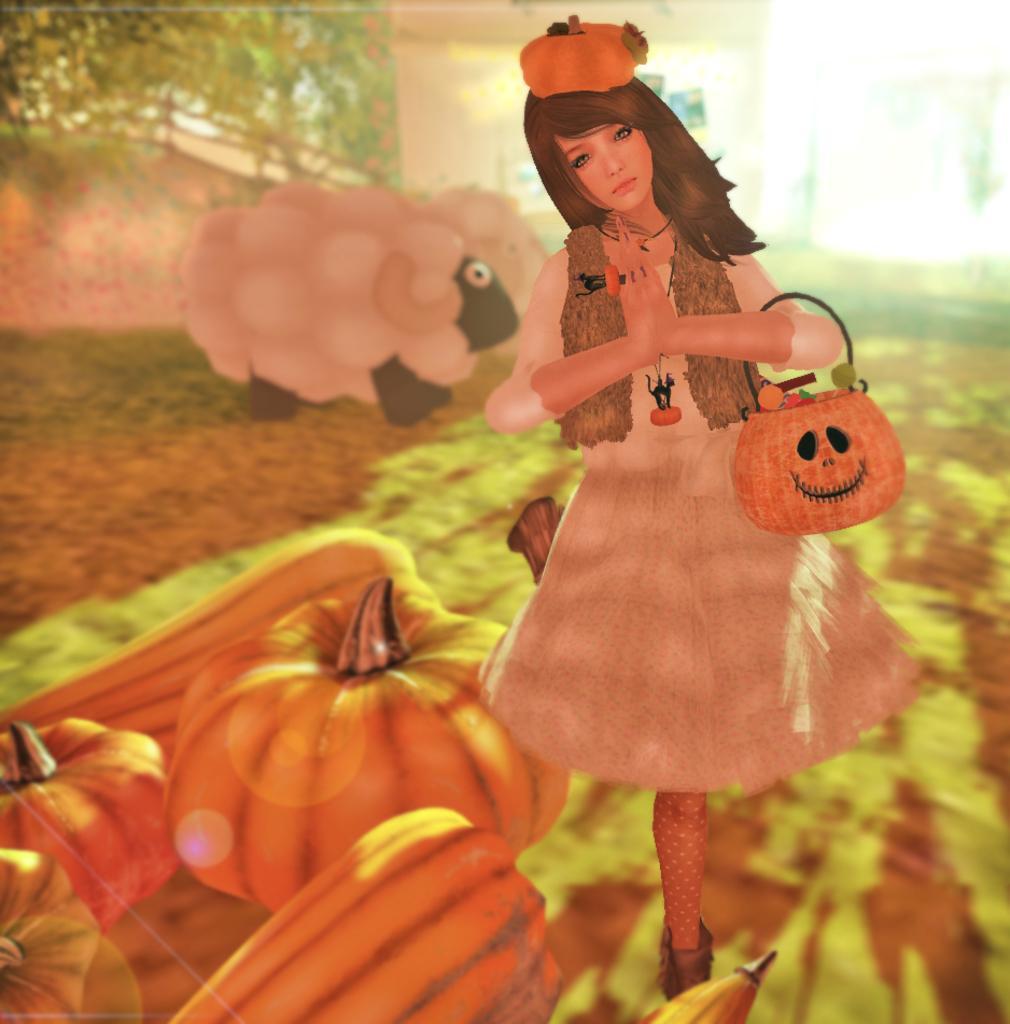How would you summarize this image in a sentence or two? This is an animation image. To the bottom left corner of the image there are few pumpkins. And in the middle of the image there is a girl with frock is standing and joined her hands. In her hand there is a basket. And on her there is a pumpkin. To the left corner of the image there are sheep. And to the top left corner of the image there is a green color. 